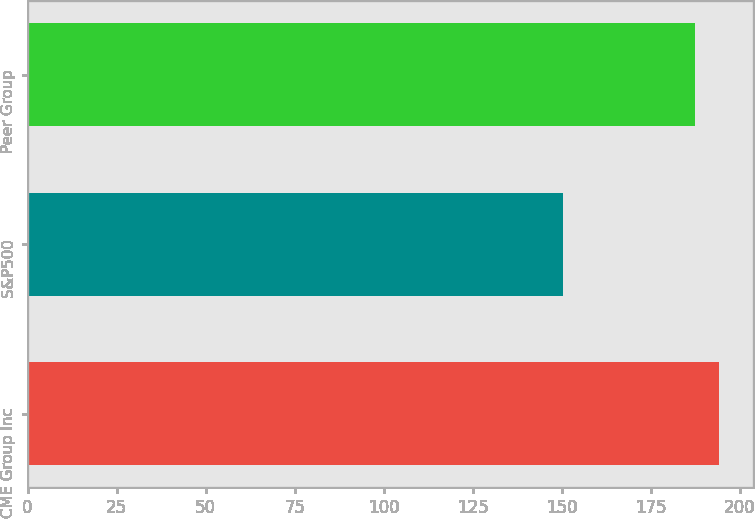<chart> <loc_0><loc_0><loc_500><loc_500><bar_chart><fcel>CME Group Inc<fcel>S&P500<fcel>Peer Group<nl><fcel>194.06<fcel>150.51<fcel>187.48<nl></chart> 